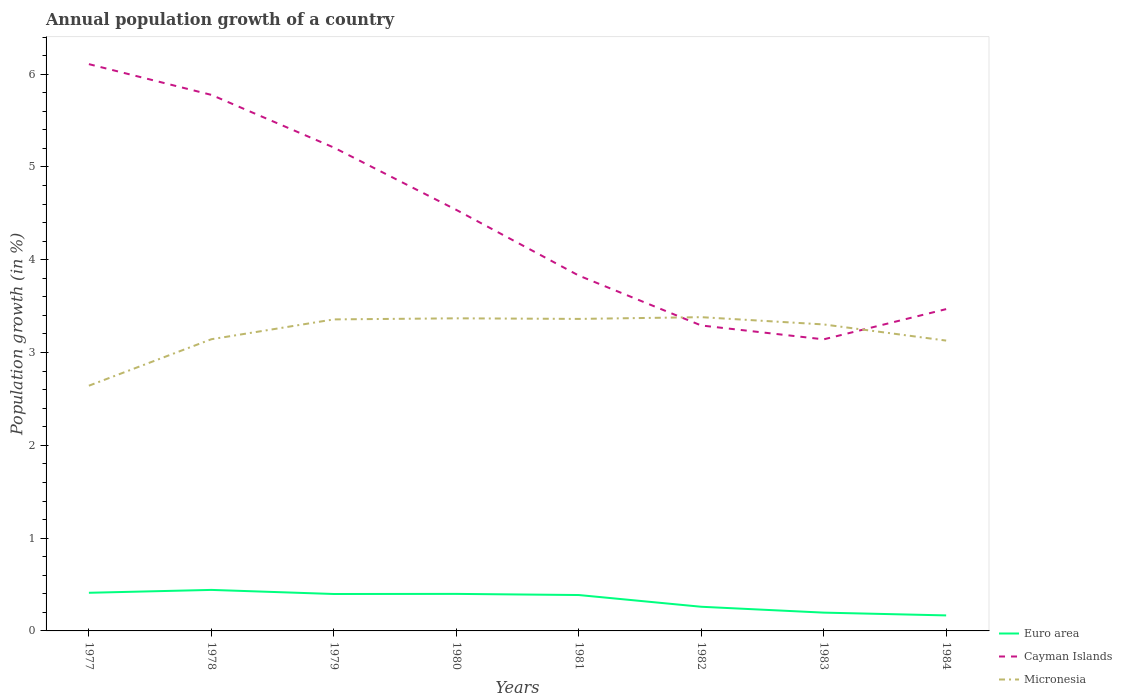Does the line corresponding to Micronesia intersect with the line corresponding to Cayman Islands?
Offer a terse response. Yes. Across all years, what is the maximum annual population growth in Cayman Islands?
Provide a succinct answer. 3.14. In which year was the annual population growth in Micronesia maximum?
Provide a short and direct response. 1977. What is the total annual population growth in Micronesia in the graph?
Offer a terse response. -0.21. What is the difference between the highest and the second highest annual population growth in Euro area?
Keep it short and to the point. 0.27. What is the difference between the highest and the lowest annual population growth in Cayman Islands?
Your response must be concise. 4. Is the annual population growth in Cayman Islands strictly greater than the annual population growth in Micronesia over the years?
Keep it short and to the point. No. How many lines are there?
Your answer should be very brief. 3. Does the graph contain any zero values?
Keep it short and to the point. No. Where does the legend appear in the graph?
Keep it short and to the point. Bottom right. How many legend labels are there?
Offer a very short reply. 3. What is the title of the graph?
Provide a short and direct response. Annual population growth of a country. Does "Guatemala" appear as one of the legend labels in the graph?
Provide a succinct answer. No. What is the label or title of the Y-axis?
Offer a terse response. Population growth (in %). What is the Population growth (in %) of Euro area in 1977?
Keep it short and to the point. 0.41. What is the Population growth (in %) in Cayman Islands in 1977?
Keep it short and to the point. 6.11. What is the Population growth (in %) in Micronesia in 1977?
Your answer should be very brief. 2.64. What is the Population growth (in %) in Euro area in 1978?
Provide a short and direct response. 0.44. What is the Population growth (in %) of Cayman Islands in 1978?
Your answer should be compact. 5.78. What is the Population growth (in %) in Micronesia in 1978?
Give a very brief answer. 3.14. What is the Population growth (in %) in Euro area in 1979?
Keep it short and to the point. 0.4. What is the Population growth (in %) of Cayman Islands in 1979?
Offer a very short reply. 5.21. What is the Population growth (in %) in Micronesia in 1979?
Give a very brief answer. 3.36. What is the Population growth (in %) in Euro area in 1980?
Give a very brief answer. 0.4. What is the Population growth (in %) in Cayman Islands in 1980?
Make the answer very short. 4.54. What is the Population growth (in %) in Micronesia in 1980?
Offer a very short reply. 3.37. What is the Population growth (in %) of Euro area in 1981?
Your response must be concise. 0.39. What is the Population growth (in %) of Cayman Islands in 1981?
Your answer should be very brief. 3.83. What is the Population growth (in %) in Micronesia in 1981?
Keep it short and to the point. 3.36. What is the Population growth (in %) of Euro area in 1982?
Make the answer very short. 0.26. What is the Population growth (in %) of Cayman Islands in 1982?
Offer a terse response. 3.29. What is the Population growth (in %) of Micronesia in 1982?
Your response must be concise. 3.38. What is the Population growth (in %) in Euro area in 1983?
Your response must be concise. 0.2. What is the Population growth (in %) in Cayman Islands in 1983?
Give a very brief answer. 3.14. What is the Population growth (in %) of Micronesia in 1983?
Make the answer very short. 3.3. What is the Population growth (in %) in Euro area in 1984?
Your response must be concise. 0.17. What is the Population growth (in %) of Cayman Islands in 1984?
Provide a short and direct response. 3.47. What is the Population growth (in %) in Micronesia in 1984?
Ensure brevity in your answer.  3.13. Across all years, what is the maximum Population growth (in %) in Euro area?
Make the answer very short. 0.44. Across all years, what is the maximum Population growth (in %) of Cayman Islands?
Make the answer very short. 6.11. Across all years, what is the maximum Population growth (in %) in Micronesia?
Your answer should be compact. 3.38. Across all years, what is the minimum Population growth (in %) in Euro area?
Your answer should be very brief. 0.17. Across all years, what is the minimum Population growth (in %) in Cayman Islands?
Make the answer very short. 3.14. Across all years, what is the minimum Population growth (in %) of Micronesia?
Keep it short and to the point. 2.64. What is the total Population growth (in %) of Euro area in the graph?
Your response must be concise. 2.66. What is the total Population growth (in %) in Cayman Islands in the graph?
Make the answer very short. 35.36. What is the total Population growth (in %) in Micronesia in the graph?
Offer a very short reply. 25.69. What is the difference between the Population growth (in %) of Euro area in 1977 and that in 1978?
Your answer should be very brief. -0.03. What is the difference between the Population growth (in %) of Cayman Islands in 1977 and that in 1978?
Your response must be concise. 0.33. What is the difference between the Population growth (in %) in Micronesia in 1977 and that in 1978?
Keep it short and to the point. -0.5. What is the difference between the Population growth (in %) of Euro area in 1977 and that in 1979?
Provide a short and direct response. 0.01. What is the difference between the Population growth (in %) of Cayman Islands in 1977 and that in 1979?
Keep it short and to the point. 0.9. What is the difference between the Population growth (in %) of Micronesia in 1977 and that in 1979?
Your response must be concise. -0.71. What is the difference between the Population growth (in %) in Euro area in 1977 and that in 1980?
Keep it short and to the point. 0.01. What is the difference between the Population growth (in %) in Cayman Islands in 1977 and that in 1980?
Provide a short and direct response. 1.57. What is the difference between the Population growth (in %) in Micronesia in 1977 and that in 1980?
Provide a succinct answer. -0.73. What is the difference between the Population growth (in %) in Euro area in 1977 and that in 1981?
Your response must be concise. 0.02. What is the difference between the Population growth (in %) in Cayman Islands in 1977 and that in 1981?
Offer a terse response. 2.28. What is the difference between the Population growth (in %) of Micronesia in 1977 and that in 1981?
Give a very brief answer. -0.72. What is the difference between the Population growth (in %) in Euro area in 1977 and that in 1982?
Give a very brief answer. 0.15. What is the difference between the Population growth (in %) of Cayman Islands in 1977 and that in 1982?
Your answer should be very brief. 2.82. What is the difference between the Population growth (in %) of Micronesia in 1977 and that in 1982?
Ensure brevity in your answer.  -0.74. What is the difference between the Population growth (in %) in Euro area in 1977 and that in 1983?
Make the answer very short. 0.21. What is the difference between the Population growth (in %) of Cayman Islands in 1977 and that in 1983?
Provide a succinct answer. 2.97. What is the difference between the Population growth (in %) of Micronesia in 1977 and that in 1983?
Give a very brief answer. -0.66. What is the difference between the Population growth (in %) in Euro area in 1977 and that in 1984?
Your answer should be very brief. 0.24. What is the difference between the Population growth (in %) of Cayman Islands in 1977 and that in 1984?
Provide a short and direct response. 2.64. What is the difference between the Population growth (in %) of Micronesia in 1977 and that in 1984?
Your answer should be very brief. -0.49. What is the difference between the Population growth (in %) in Euro area in 1978 and that in 1979?
Offer a terse response. 0.04. What is the difference between the Population growth (in %) of Cayman Islands in 1978 and that in 1979?
Provide a short and direct response. 0.57. What is the difference between the Population growth (in %) in Micronesia in 1978 and that in 1979?
Provide a short and direct response. -0.21. What is the difference between the Population growth (in %) of Euro area in 1978 and that in 1980?
Your answer should be very brief. 0.04. What is the difference between the Population growth (in %) of Cayman Islands in 1978 and that in 1980?
Make the answer very short. 1.24. What is the difference between the Population growth (in %) of Micronesia in 1978 and that in 1980?
Your response must be concise. -0.23. What is the difference between the Population growth (in %) in Euro area in 1978 and that in 1981?
Your answer should be compact. 0.06. What is the difference between the Population growth (in %) of Cayman Islands in 1978 and that in 1981?
Keep it short and to the point. 1.95. What is the difference between the Population growth (in %) of Micronesia in 1978 and that in 1981?
Ensure brevity in your answer.  -0.22. What is the difference between the Population growth (in %) in Euro area in 1978 and that in 1982?
Your answer should be very brief. 0.18. What is the difference between the Population growth (in %) in Cayman Islands in 1978 and that in 1982?
Provide a short and direct response. 2.48. What is the difference between the Population growth (in %) of Micronesia in 1978 and that in 1982?
Your answer should be very brief. -0.24. What is the difference between the Population growth (in %) of Euro area in 1978 and that in 1983?
Offer a terse response. 0.24. What is the difference between the Population growth (in %) of Cayman Islands in 1978 and that in 1983?
Make the answer very short. 2.63. What is the difference between the Population growth (in %) of Micronesia in 1978 and that in 1983?
Provide a short and direct response. -0.16. What is the difference between the Population growth (in %) in Euro area in 1978 and that in 1984?
Make the answer very short. 0.27. What is the difference between the Population growth (in %) of Cayman Islands in 1978 and that in 1984?
Give a very brief answer. 2.31. What is the difference between the Population growth (in %) of Micronesia in 1978 and that in 1984?
Offer a terse response. 0.01. What is the difference between the Population growth (in %) in Euro area in 1979 and that in 1980?
Your answer should be compact. -0. What is the difference between the Population growth (in %) in Cayman Islands in 1979 and that in 1980?
Your answer should be compact. 0.67. What is the difference between the Population growth (in %) in Micronesia in 1979 and that in 1980?
Keep it short and to the point. -0.01. What is the difference between the Population growth (in %) of Euro area in 1979 and that in 1981?
Make the answer very short. 0.01. What is the difference between the Population growth (in %) of Cayman Islands in 1979 and that in 1981?
Offer a terse response. 1.38. What is the difference between the Population growth (in %) of Micronesia in 1979 and that in 1981?
Your response must be concise. -0.01. What is the difference between the Population growth (in %) of Euro area in 1979 and that in 1982?
Provide a succinct answer. 0.14. What is the difference between the Population growth (in %) in Cayman Islands in 1979 and that in 1982?
Offer a very short reply. 1.92. What is the difference between the Population growth (in %) in Micronesia in 1979 and that in 1982?
Your answer should be compact. -0.02. What is the difference between the Population growth (in %) of Euro area in 1979 and that in 1983?
Offer a terse response. 0.2. What is the difference between the Population growth (in %) of Cayman Islands in 1979 and that in 1983?
Give a very brief answer. 2.07. What is the difference between the Population growth (in %) of Micronesia in 1979 and that in 1983?
Give a very brief answer. 0.05. What is the difference between the Population growth (in %) of Euro area in 1979 and that in 1984?
Offer a terse response. 0.23. What is the difference between the Population growth (in %) of Cayman Islands in 1979 and that in 1984?
Keep it short and to the point. 1.74. What is the difference between the Population growth (in %) of Micronesia in 1979 and that in 1984?
Provide a succinct answer. 0.23. What is the difference between the Population growth (in %) in Euro area in 1980 and that in 1981?
Your response must be concise. 0.01. What is the difference between the Population growth (in %) of Cayman Islands in 1980 and that in 1981?
Your answer should be very brief. 0.71. What is the difference between the Population growth (in %) in Micronesia in 1980 and that in 1981?
Provide a succinct answer. 0.01. What is the difference between the Population growth (in %) in Euro area in 1980 and that in 1982?
Offer a very short reply. 0.14. What is the difference between the Population growth (in %) in Cayman Islands in 1980 and that in 1982?
Provide a succinct answer. 1.25. What is the difference between the Population growth (in %) in Micronesia in 1980 and that in 1982?
Make the answer very short. -0.01. What is the difference between the Population growth (in %) in Euro area in 1980 and that in 1983?
Provide a short and direct response. 0.2. What is the difference between the Population growth (in %) in Cayman Islands in 1980 and that in 1983?
Your answer should be very brief. 1.4. What is the difference between the Population growth (in %) in Micronesia in 1980 and that in 1983?
Provide a succinct answer. 0.07. What is the difference between the Population growth (in %) of Euro area in 1980 and that in 1984?
Your answer should be compact. 0.23. What is the difference between the Population growth (in %) of Cayman Islands in 1980 and that in 1984?
Provide a succinct answer. 1.07. What is the difference between the Population growth (in %) of Micronesia in 1980 and that in 1984?
Make the answer very short. 0.24. What is the difference between the Population growth (in %) in Euro area in 1981 and that in 1982?
Make the answer very short. 0.13. What is the difference between the Population growth (in %) in Cayman Islands in 1981 and that in 1982?
Provide a short and direct response. 0.54. What is the difference between the Population growth (in %) of Micronesia in 1981 and that in 1982?
Offer a terse response. -0.02. What is the difference between the Population growth (in %) of Euro area in 1981 and that in 1983?
Your answer should be very brief. 0.19. What is the difference between the Population growth (in %) of Cayman Islands in 1981 and that in 1983?
Your answer should be very brief. 0.69. What is the difference between the Population growth (in %) of Micronesia in 1981 and that in 1983?
Keep it short and to the point. 0.06. What is the difference between the Population growth (in %) of Euro area in 1981 and that in 1984?
Keep it short and to the point. 0.22. What is the difference between the Population growth (in %) of Cayman Islands in 1981 and that in 1984?
Give a very brief answer. 0.36. What is the difference between the Population growth (in %) of Micronesia in 1981 and that in 1984?
Your answer should be compact. 0.23. What is the difference between the Population growth (in %) of Euro area in 1982 and that in 1983?
Your answer should be compact. 0.06. What is the difference between the Population growth (in %) of Cayman Islands in 1982 and that in 1983?
Your answer should be very brief. 0.15. What is the difference between the Population growth (in %) of Micronesia in 1982 and that in 1983?
Offer a terse response. 0.08. What is the difference between the Population growth (in %) in Euro area in 1982 and that in 1984?
Your answer should be compact. 0.09. What is the difference between the Population growth (in %) of Cayman Islands in 1982 and that in 1984?
Provide a succinct answer. -0.18. What is the difference between the Population growth (in %) of Micronesia in 1982 and that in 1984?
Offer a terse response. 0.25. What is the difference between the Population growth (in %) in Euro area in 1983 and that in 1984?
Give a very brief answer. 0.03. What is the difference between the Population growth (in %) of Cayman Islands in 1983 and that in 1984?
Provide a short and direct response. -0.33. What is the difference between the Population growth (in %) in Micronesia in 1983 and that in 1984?
Provide a succinct answer. 0.17. What is the difference between the Population growth (in %) of Euro area in 1977 and the Population growth (in %) of Cayman Islands in 1978?
Provide a succinct answer. -5.37. What is the difference between the Population growth (in %) of Euro area in 1977 and the Population growth (in %) of Micronesia in 1978?
Your response must be concise. -2.73. What is the difference between the Population growth (in %) of Cayman Islands in 1977 and the Population growth (in %) of Micronesia in 1978?
Your answer should be very brief. 2.96. What is the difference between the Population growth (in %) of Euro area in 1977 and the Population growth (in %) of Cayman Islands in 1979?
Your answer should be compact. -4.8. What is the difference between the Population growth (in %) in Euro area in 1977 and the Population growth (in %) in Micronesia in 1979?
Give a very brief answer. -2.95. What is the difference between the Population growth (in %) in Cayman Islands in 1977 and the Population growth (in %) in Micronesia in 1979?
Offer a very short reply. 2.75. What is the difference between the Population growth (in %) of Euro area in 1977 and the Population growth (in %) of Cayman Islands in 1980?
Keep it short and to the point. -4.13. What is the difference between the Population growth (in %) in Euro area in 1977 and the Population growth (in %) in Micronesia in 1980?
Your answer should be very brief. -2.96. What is the difference between the Population growth (in %) of Cayman Islands in 1977 and the Population growth (in %) of Micronesia in 1980?
Keep it short and to the point. 2.74. What is the difference between the Population growth (in %) of Euro area in 1977 and the Population growth (in %) of Cayman Islands in 1981?
Your answer should be compact. -3.42. What is the difference between the Population growth (in %) in Euro area in 1977 and the Population growth (in %) in Micronesia in 1981?
Ensure brevity in your answer.  -2.95. What is the difference between the Population growth (in %) in Cayman Islands in 1977 and the Population growth (in %) in Micronesia in 1981?
Provide a succinct answer. 2.75. What is the difference between the Population growth (in %) of Euro area in 1977 and the Population growth (in %) of Cayman Islands in 1982?
Provide a succinct answer. -2.88. What is the difference between the Population growth (in %) in Euro area in 1977 and the Population growth (in %) in Micronesia in 1982?
Ensure brevity in your answer.  -2.97. What is the difference between the Population growth (in %) of Cayman Islands in 1977 and the Population growth (in %) of Micronesia in 1982?
Your response must be concise. 2.73. What is the difference between the Population growth (in %) in Euro area in 1977 and the Population growth (in %) in Cayman Islands in 1983?
Provide a succinct answer. -2.73. What is the difference between the Population growth (in %) in Euro area in 1977 and the Population growth (in %) in Micronesia in 1983?
Offer a very short reply. -2.89. What is the difference between the Population growth (in %) of Cayman Islands in 1977 and the Population growth (in %) of Micronesia in 1983?
Give a very brief answer. 2.81. What is the difference between the Population growth (in %) of Euro area in 1977 and the Population growth (in %) of Cayman Islands in 1984?
Provide a short and direct response. -3.06. What is the difference between the Population growth (in %) in Euro area in 1977 and the Population growth (in %) in Micronesia in 1984?
Provide a succinct answer. -2.72. What is the difference between the Population growth (in %) of Cayman Islands in 1977 and the Population growth (in %) of Micronesia in 1984?
Your response must be concise. 2.98. What is the difference between the Population growth (in %) of Euro area in 1978 and the Population growth (in %) of Cayman Islands in 1979?
Provide a succinct answer. -4.77. What is the difference between the Population growth (in %) in Euro area in 1978 and the Population growth (in %) in Micronesia in 1979?
Offer a terse response. -2.92. What is the difference between the Population growth (in %) of Cayman Islands in 1978 and the Population growth (in %) of Micronesia in 1979?
Your answer should be very brief. 2.42. What is the difference between the Population growth (in %) in Euro area in 1978 and the Population growth (in %) in Cayman Islands in 1980?
Keep it short and to the point. -4.1. What is the difference between the Population growth (in %) in Euro area in 1978 and the Population growth (in %) in Micronesia in 1980?
Make the answer very short. -2.93. What is the difference between the Population growth (in %) of Cayman Islands in 1978 and the Population growth (in %) of Micronesia in 1980?
Offer a terse response. 2.41. What is the difference between the Population growth (in %) in Euro area in 1978 and the Population growth (in %) in Cayman Islands in 1981?
Provide a short and direct response. -3.39. What is the difference between the Population growth (in %) of Euro area in 1978 and the Population growth (in %) of Micronesia in 1981?
Your response must be concise. -2.92. What is the difference between the Population growth (in %) in Cayman Islands in 1978 and the Population growth (in %) in Micronesia in 1981?
Provide a short and direct response. 2.41. What is the difference between the Population growth (in %) in Euro area in 1978 and the Population growth (in %) in Cayman Islands in 1982?
Make the answer very short. -2.85. What is the difference between the Population growth (in %) in Euro area in 1978 and the Population growth (in %) in Micronesia in 1982?
Your answer should be very brief. -2.94. What is the difference between the Population growth (in %) of Cayman Islands in 1978 and the Population growth (in %) of Micronesia in 1982?
Your response must be concise. 2.4. What is the difference between the Population growth (in %) of Euro area in 1978 and the Population growth (in %) of Micronesia in 1983?
Offer a very short reply. -2.86. What is the difference between the Population growth (in %) in Cayman Islands in 1978 and the Population growth (in %) in Micronesia in 1983?
Ensure brevity in your answer.  2.47. What is the difference between the Population growth (in %) in Euro area in 1978 and the Population growth (in %) in Cayman Islands in 1984?
Ensure brevity in your answer.  -3.03. What is the difference between the Population growth (in %) in Euro area in 1978 and the Population growth (in %) in Micronesia in 1984?
Keep it short and to the point. -2.69. What is the difference between the Population growth (in %) of Cayman Islands in 1978 and the Population growth (in %) of Micronesia in 1984?
Make the answer very short. 2.65. What is the difference between the Population growth (in %) of Euro area in 1979 and the Population growth (in %) of Cayman Islands in 1980?
Provide a short and direct response. -4.14. What is the difference between the Population growth (in %) of Euro area in 1979 and the Population growth (in %) of Micronesia in 1980?
Offer a terse response. -2.97. What is the difference between the Population growth (in %) of Cayman Islands in 1979 and the Population growth (in %) of Micronesia in 1980?
Make the answer very short. 1.84. What is the difference between the Population growth (in %) in Euro area in 1979 and the Population growth (in %) in Cayman Islands in 1981?
Offer a very short reply. -3.43. What is the difference between the Population growth (in %) of Euro area in 1979 and the Population growth (in %) of Micronesia in 1981?
Your answer should be compact. -2.96. What is the difference between the Population growth (in %) of Cayman Islands in 1979 and the Population growth (in %) of Micronesia in 1981?
Your response must be concise. 1.85. What is the difference between the Population growth (in %) in Euro area in 1979 and the Population growth (in %) in Cayman Islands in 1982?
Give a very brief answer. -2.89. What is the difference between the Population growth (in %) in Euro area in 1979 and the Population growth (in %) in Micronesia in 1982?
Give a very brief answer. -2.98. What is the difference between the Population growth (in %) in Cayman Islands in 1979 and the Population growth (in %) in Micronesia in 1982?
Give a very brief answer. 1.83. What is the difference between the Population growth (in %) in Euro area in 1979 and the Population growth (in %) in Cayman Islands in 1983?
Give a very brief answer. -2.74. What is the difference between the Population growth (in %) in Euro area in 1979 and the Population growth (in %) in Micronesia in 1983?
Make the answer very short. -2.9. What is the difference between the Population growth (in %) in Cayman Islands in 1979 and the Population growth (in %) in Micronesia in 1983?
Make the answer very short. 1.91. What is the difference between the Population growth (in %) in Euro area in 1979 and the Population growth (in %) in Cayman Islands in 1984?
Offer a very short reply. -3.07. What is the difference between the Population growth (in %) in Euro area in 1979 and the Population growth (in %) in Micronesia in 1984?
Your answer should be compact. -2.73. What is the difference between the Population growth (in %) of Cayman Islands in 1979 and the Population growth (in %) of Micronesia in 1984?
Keep it short and to the point. 2.08. What is the difference between the Population growth (in %) in Euro area in 1980 and the Population growth (in %) in Cayman Islands in 1981?
Keep it short and to the point. -3.43. What is the difference between the Population growth (in %) of Euro area in 1980 and the Population growth (in %) of Micronesia in 1981?
Ensure brevity in your answer.  -2.96. What is the difference between the Population growth (in %) of Cayman Islands in 1980 and the Population growth (in %) of Micronesia in 1981?
Offer a terse response. 1.18. What is the difference between the Population growth (in %) of Euro area in 1980 and the Population growth (in %) of Cayman Islands in 1982?
Offer a terse response. -2.89. What is the difference between the Population growth (in %) in Euro area in 1980 and the Population growth (in %) in Micronesia in 1982?
Make the answer very short. -2.98. What is the difference between the Population growth (in %) in Cayman Islands in 1980 and the Population growth (in %) in Micronesia in 1982?
Your response must be concise. 1.16. What is the difference between the Population growth (in %) in Euro area in 1980 and the Population growth (in %) in Cayman Islands in 1983?
Provide a succinct answer. -2.74. What is the difference between the Population growth (in %) in Euro area in 1980 and the Population growth (in %) in Micronesia in 1983?
Make the answer very short. -2.9. What is the difference between the Population growth (in %) of Cayman Islands in 1980 and the Population growth (in %) of Micronesia in 1983?
Provide a succinct answer. 1.23. What is the difference between the Population growth (in %) in Euro area in 1980 and the Population growth (in %) in Cayman Islands in 1984?
Your response must be concise. -3.07. What is the difference between the Population growth (in %) in Euro area in 1980 and the Population growth (in %) in Micronesia in 1984?
Offer a terse response. -2.73. What is the difference between the Population growth (in %) of Cayman Islands in 1980 and the Population growth (in %) of Micronesia in 1984?
Provide a succinct answer. 1.41. What is the difference between the Population growth (in %) of Euro area in 1981 and the Population growth (in %) of Cayman Islands in 1982?
Offer a very short reply. -2.9. What is the difference between the Population growth (in %) of Euro area in 1981 and the Population growth (in %) of Micronesia in 1982?
Give a very brief answer. -2.99. What is the difference between the Population growth (in %) of Cayman Islands in 1981 and the Population growth (in %) of Micronesia in 1982?
Make the answer very short. 0.45. What is the difference between the Population growth (in %) of Euro area in 1981 and the Population growth (in %) of Cayman Islands in 1983?
Give a very brief answer. -2.76. What is the difference between the Population growth (in %) of Euro area in 1981 and the Population growth (in %) of Micronesia in 1983?
Your answer should be compact. -2.92. What is the difference between the Population growth (in %) in Cayman Islands in 1981 and the Population growth (in %) in Micronesia in 1983?
Offer a terse response. 0.53. What is the difference between the Population growth (in %) in Euro area in 1981 and the Population growth (in %) in Cayman Islands in 1984?
Offer a very short reply. -3.08. What is the difference between the Population growth (in %) of Euro area in 1981 and the Population growth (in %) of Micronesia in 1984?
Provide a succinct answer. -2.74. What is the difference between the Population growth (in %) of Cayman Islands in 1981 and the Population growth (in %) of Micronesia in 1984?
Your response must be concise. 0.7. What is the difference between the Population growth (in %) in Euro area in 1982 and the Population growth (in %) in Cayman Islands in 1983?
Make the answer very short. -2.88. What is the difference between the Population growth (in %) of Euro area in 1982 and the Population growth (in %) of Micronesia in 1983?
Offer a terse response. -3.04. What is the difference between the Population growth (in %) of Cayman Islands in 1982 and the Population growth (in %) of Micronesia in 1983?
Provide a succinct answer. -0.01. What is the difference between the Population growth (in %) of Euro area in 1982 and the Population growth (in %) of Cayman Islands in 1984?
Offer a terse response. -3.21. What is the difference between the Population growth (in %) in Euro area in 1982 and the Population growth (in %) in Micronesia in 1984?
Give a very brief answer. -2.87. What is the difference between the Population growth (in %) in Cayman Islands in 1982 and the Population growth (in %) in Micronesia in 1984?
Give a very brief answer. 0.16. What is the difference between the Population growth (in %) of Euro area in 1983 and the Population growth (in %) of Cayman Islands in 1984?
Offer a terse response. -3.27. What is the difference between the Population growth (in %) in Euro area in 1983 and the Population growth (in %) in Micronesia in 1984?
Your answer should be very brief. -2.93. What is the difference between the Population growth (in %) of Cayman Islands in 1983 and the Population growth (in %) of Micronesia in 1984?
Provide a short and direct response. 0.01. What is the average Population growth (in %) of Euro area per year?
Make the answer very short. 0.33. What is the average Population growth (in %) in Cayman Islands per year?
Your response must be concise. 4.42. What is the average Population growth (in %) of Micronesia per year?
Make the answer very short. 3.21. In the year 1977, what is the difference between the Population growth (in %) in Euro area and Population growth (in %) in Cayman Islands?
Provide a succinct answer. -5.7. In the year 1977, what is the difference between the Population growth (in %) of Euro area and Population growth (in %) of Micronesia?
Provide a short and direct response. -2.23. In the year 1977, what is the difference between the Population growth (in %) in Cayman Islands and Population growth (in %) in Micronesia?
Offer a terse response. 3.47. In the year 1978, what is the difference between the Population growth (in %) in Euro area and Population growth (in %) in Cayman Islands?
Offer a terse response. -5.33. In the year 1978, what is the difference between the Population growth (in %) in Euro area and Population growth (in %) in Micronesia?
Your answer should be very brief. -2.7. In the year 1978, what is the difference between the Population growth (in %) in Cayman Islands and Population growth (in %) in Micronesia?
Offer a very short reply. 2.63. In the year 1979, what is the difference between the Population growth (in %) in Euro area and Population growth (in %) in Cayman Islands?
Provide a short and direct response. -4.81. In the year 1979, what is the difference between the Population growth (in %) in Euro area and Population growth (in %) in Micronesia?
Provide a short and direct response. -2.96. In the year 1979, what is the difference between the Population growth (in %) of Cayman Islands and Population growth (in %) of Micronesia?
Make the answer very short. 1.85. In the year 1980, what is the difference between the Population growth (in %) in Euro area and Population growth (in %) in Cayman Islands?
Keep it short and to the point. -4.14. In the year 1980, what is the difference between the Population growth (in %) of Euro area and Population growth (in %) of Micronesia?
Provide a short and direct response. -2.97. In the year 1980, what is the difference between the Population growth (in %) in Cayman Islands and Population growth (in %) in Micronesia?
Provide a short and direct response. 1.17. In the year 1981, what is the difference between the Population growth (in %) of Euro area and Population growth (in %) of Cayman Islands?
Offer a very short reply. -3.44. In the year 1981, what is the difference between the Population growth (in %) of Euro area and Population growth (in %) of Micronesia?
Your answer should be very brief. -2.98. In the year 1981, what is the difference between the Population growth (in %) in Cayman Islands and Population growth (in %) in Micronesia?
Provide a succinct answer. 0.47. In the year 1982, what is the difference between the Population growth (in %) in Euro area and Population growth (in %) in Cayman Islands?
Make the answer very short. -3.03. In the year 1982, what is the difference between the Population growth (in %) of Euro area and Population growth (in %) of Micronesia?
Make the answer very short. -3.12. In the year 1982, what is the difference between the Population growth (in %) of Cayman Islands and Population growth (in %) of Micronesia?
Your response must be concise. -0.09. In the year 1983, what is the difference between the Population growth (in %) in Euro area and Population growth (in %) in Cayman Islands?
Your response must be concise. -2.94. In the year 1983, what is the difference between the Population growth (in %) in Euro area and Population growth (in %) in Micronesia?
Give a very brief answer. -3.11. In the year 1983, what is the difference between the Population growth (in %) in Cayman Islands and Population growth (in %) in Micronesia?
Provide a succinct answer. -0.16. In the year 1984, what is the difference between the Population growth (in %) of Euro area and Population growth (in %) of Cayman Islands?
Provide a succinct answer. -3.3. In the year 1984, what is the difference between the Population growth (in %) in Euro area and Population growth (in %) in Micronesia?
Offer a very short reply. -2.96. In the year 1984, what is the difference between the Population growth (in %) of Cayman Islands and Population growth (in %) of Micronesia?
Ensure brevity in your answer.  0.34. What is the ratio of the Population growth (in %) in Euro area in 1977 to that in 1978?
Make the answer very short. 0.93. What is the ratio of the Population growth (in %) of Cayman Islands in 1977 to that in 1978?
Provide a short and direct response. 1.06. What is the ratio of the Population growth (in %) of Micronesia in 1977 to that in 1978?
Provide a succinct answer. 0.84. What is the ratio of the Population growth (in %) of Euro area in 1977 to that in 1979?
Provide a short and direct response. 1.03. What is the ratio of the Population growth (in %) of Cayman Islands in 1977 to that in 1979?
Offer a terse response. 1.17. What is the ratio of the Population growth (in %) of Micronesia in 1977 to that in 1979?
Make the answer very short. 0.79. What is the ratio of the Population growth (in %) of Euro area in 1977 to that in 1980?
Ensure brevity in your answer.  1.03. What is the ratio of the Population growth (in %) in Cayman Islands in 1977 to that in 1980?
Provide a short and direct response. 1.35. What is the ratio of the Population growth (in %) in Micronesia in 1977 to that in 1980?
Your answer should be very brief. 0.78. What is the ratio of the Population growth (in %) in Euro area in 1977 to that in 1981?
Ensure brevity in your answer.  1.06. What is the ratio of the Population growth (in %) in Cayman Islands in 1977 to that in 1981?
Keep it short and to the point. 1.59. What is the ratio of the Population growth (in %) of Micronesia in 1977 to that in 1981?
Ensure brevity in your answer.  0.79. What is the ratio of the Population growth (in %) in Euro area in 1977 to that in 1982?
Keep it short and to the point. 1.58. What is the ratio of the Population growth (in %) in Cayman Islands in 1977 to that in 1982?
Keep it short and to the point. 1.86. What is the ratio of the Population growth (in %) of Micronesia in 1977 to that in 1982?
Provide a succinct answer. 0.78. What is the ratio of the Population growth (in %) of Euro area in 1977 to that in 1983?
Provide a short and direct response. 2.08. What is the ratio of the Population growth (in %) in Cayman Islands in 1977 to that in 1983?
Your response must be concise. 1.94. What is the ratio of the Population growth (in %) in Micronesia in 1977 to that in 1983?
Ensure brevity in your answer.  0.8. What is the ratio of the Population growth (in %) in Euro area in 1977 to that in 1984?
Your response must be concise. 2.46. What is the ratio of the Population growth (in %) of Cayman Islands in 1977 to that in 1984?
Offer a very short reply. 1.76. What is the ratio of the Population growth (in %) in Micronesia in 1977 to that in 1984?
Your response must be concise. 0.84. What is the ratio of the Population growth (in %) of Euro area in 1978 to that in 1979?
Your answer should be compact. 1.11. What is the ratio of the Population growth (in %) in Cayman Islands in 1978 to that in 1979?
Give a very brief answer. 1.11. What is the ratio of the Population growth (in %) of Micronesia in 1978 to that in 1979?
Make the answer very short. 0.94. What is the ratio of the Population growth (in %) in Euro area in 1978 to that in 1980?
Your answer should be very brief. 1.11. What is the ratio of the Population growth (in %) in Cayman Islands in 1978 to that in 1980?
Make the answer very short. 1.27. What is the ratio of the Population growth (in %) in Micronesia in 1978 to that in 1980?
Give a very brief answer. 0.93. What is the ratio of the Population growth (in %) of Euro area in 1978 to that in 1981?
Ensure brevity in your answer.  1.14. What is the ratio of the Population growth (in %) of Cayman Islands in 1978 to that in 1981?
Your response must be concise. 1.51. What is the ratio of the Population growth (in %) in Micronesia in 1978 to that in 1981?
Offer a terse response. 0.93. What is the ratio of the Population growth (in %) of Euro area in 1978 to that in 1982?
Ensure brevity in your answer.  1.7. What is the ratio of the Population growth (in %) of Cayman Islands in 1978 to that in 1982?
Your response must be concise. 1.75. What is the ratio of the Population growth (in %) in Micronesia in 1978 to that in 1982?
Provide a succinct answer. 0.93. What is the ratio of the Population growth (in %) in Euro area in 1978 to that in 1983?
Offer a very short reply. 2.24. What is the ratio of the Population growth (in %) of Cayman Islands in 1978 to that in 1983?
Ensure brevity in your answer.  1.84. What is the ratio of the Population growth (in %) in Micronesia in 1978 to that in 1983?
Give a very brief answer. 0.95. What is the ratio of the Population growth (in %) of Euro area in 1978 to that in 1984?
Ensure brevity in your answer.  2.64. What is the ratio of the Population growth (in %) in Cayman Islands in 1978 to that in 1984?
Provide a short and direct response. 1.67. What is the ratio of the Population growth (in %) in Micronesia in 1978 to that in 1984?
Your answer should be compact. 1. What is the ratio of the Population growth (in %) in Cayman Islands in 1979 to that in 1980?
Offer a terse response. 1.15. What is the ratio of the Population growth (in %) of Micronesia in 1979 to that in 1980?
Offer a terse response. 1. What is the ratio of the Population growth (in %) in Euro area in 1979 to that in 1981?
Your answer should be very brief. 1.03. What is the ratio of the Population growth (in %) in Cayman Islands in 1979 to that in 1981?
Keep it short and to the point. 1.36. What is the ratio of the Population growth (in %) in Micronesia in 1979 to that in 1981?
Give a very brief answer. 1. What is the ratio of the Population growth (in %) in Euro area in 1979 to that in 1982?
Ensure brevity in your answer.  1.53. What is the ratio of the Population growth (in %) in Cayman Islands in 1979 to that in 1982?
Your answer should be very brief. 1.58. What is the ratio of the Population growth (in %) of Euro area in 1979 to that in 1983?
Give a very brief answer. 2.02. What is the ratio of the Population growth (in %) of Cayman Islands in 1979 to that in 1983?
Make the answer very short. 1.66. What is the ratio of the Population growth (in %) in Micronesia in 1979 to that in 1983?
Provide a succinct answer. 1.02. What is the ratio of the Population growth (in %) of Euro area in 1979 to that in 1984?
Make the answer very short. 2.38. What is the ratio of the Population growth (in %) in Cayman Islands in 1979 to that in 1984?
Keep it short and to the point. 1.5. What is the ratio of the Population growth (in %) of Micronesia in 1979 to that in 1984?
Provide a short and direct response. 1.07. What is the ratio of the Population growth (in %) in Euro area in 1980 to that in 1981?
Your answer should be very brief. 1.03. What is the ratio of the Population growth (in %) of Cayman Islands in 1980 to that in 1981?
Provide a succinct answer. 1.18. What is the ratio of the Population growth (in %) of Micronesia in 1980 to that in 1981?
Provide a succinct answer. 1. What is the ratio of the Population growth (in %) of Euro area in 1980 to that in 1982?
Offer a very short reply. 1.53. What is the ratio of the Population growth (in %) of Cayman Islands in 1980 to that in 1982?
Provide a short and direct response. 1.38. What is the ratio of the Population growth (in %) of Micronesia in 1980 to that in 1982?
Keep it short and to the point. 1. What is the ratio of the Population growth (in %) of Euro area in 1980 to that in 1983?
Ensure brevity in your answer.  2.02. What is the ratio of the Population growth (in %) of Cayman Islands in 1980 to that in 1983?
Provide a short and direct response. 1.44. What is the ratio of the Population growth (in %) in Micronesia in 1980 to that in 1983?
Make the answer very short. 1.02. What is the ratio of the Population growth (in %) in Euro area in 1980 to that in 1984?
Your answer should be compact. 2.39. What is the ratio of the Population growth (in %) of Cayman Islands in 1980 to that in 1984?
Offer a very short reply. 1.31. What is the ratio of the Population growth (in %) in Micronesia in 1980 to that in 1984?
Make the answer very short. 1.08. What is the ratio of the Population growth (in %) in Euro area in 1981 to that in 1982?
Your answer should be very brief. 1.49. What is the ratio of the Population growth (in %) in Cayman Islands in 1981 to that in 1982?
Provide a short and direct response. 1.16. What is the ratio of the Population growth (in %) in Euro area in 1981 to that in 1983?
Provide a short and direct response. 1.96. What is the ratio of the Population growth (in %) in Cayman Islands in 1981 to that in 1983?
Provide a short and direct response. 1.22. What is the ratio of the Population growth (in %) of Micronesia in 1981 to that in 1983?
Your answer should be very brief. 1.02. What is the ratio of the Population growth (in %) in Euro area in 1981 to that in 1984?
Provide a short and direct response. 2.31. What is the ratio of the Population growth (in %) of Cayman Islands in 1981 to that in 1984?
Make the answer very short. 1.1. What is the ratio of the Population growth (in %) of Micronesia in 1981 to that in 1984?
Keep it short and to the point. 1.07. What is the ratio of the Population growth (in %) of Euro area in 1982 to that in 1983?
Offer a very short reply. 1.32. What is the ratio of the Population growth (in %) of Cayman Islands in 1982 to that in 1983?
Provide a succinct answer. 1.05. What is the ratio of the Population growth (in %) in Micronesia in 1982 to that in 1983?
Provide a short and direct response. 1.02. What is the ratio of the Population growth (in %) of Euro area in 1982 to that in 1984?
Ensure brevity in your answer.  1.56. What is the ratio of the Population growth (in %) in Cayman Islands in 1982 to that in 1984?
Ensure brevity in your answer.  0.95. What is the ratio of the Population growth (in %) in Micronesia in 1982 to that in 1984?
Offer a very short reply. 1.08. What is the ratio of the Population growth (in %) in Euro area in 1983 to that in 1984?
Keep it short and to the point. 1.18. What is the ratio of the Population growth (in %) of Cayman Islands in 1983 to that in 1984?
Offer a terse response. 0.91. What is the ratio of the Population growth (in %) in Micronesia in 1983 to that in 1984?
Offer a terse response. 1.06. What is the difference between the highest and the second highest Population growth (in %) of Euro area?
Your answer should be very brief. 0.03. What is the difference between the highest and the second highest Population growth (in %) in Cayman Islands?
Provide a succinct answer. 0.33. What is the difference between the highest and the second highest Population growth (in %) in Micronesia?
Provide a short and direct response. 0.01. What is the difference between the highest and the lowest Population growth (in %) of Euro area?
Ensure brevity in your answer.  0.27. What is the difference between the highest and the lowest Population growth (in %) of Cayman Islands?
Offer a terse response. 2.97. What is the difference between the highest and the lowest Population growth (in %) in Micronesia?
Offer a very short reply. 0.74. 